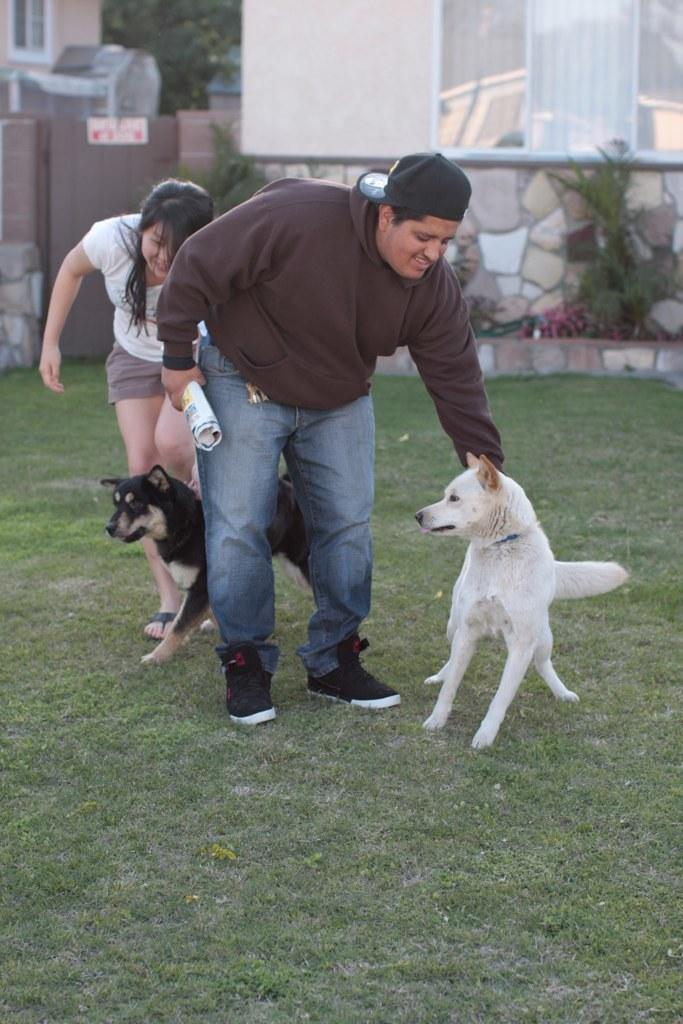Who or what can be seen in the image? There are persons and dogs in the image. What is one of the persons holding in their hand? A person is holding a paper in their hand. What is visible in the top right of the image? There is a wall in the top right of the image. How does the dirt affect the rainstorm in the image? There is no dirt or rainstorm present in the image. 